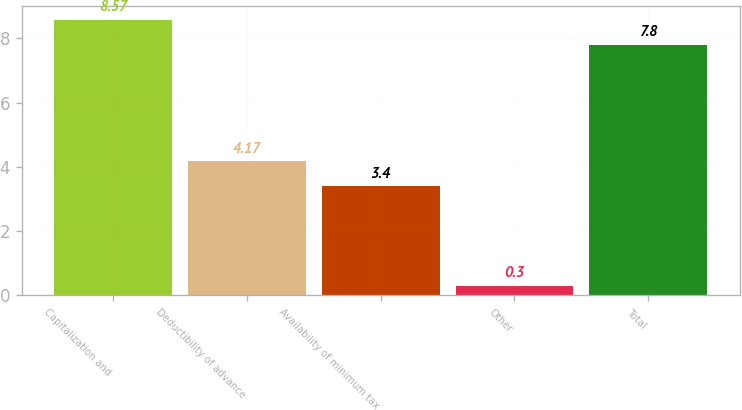<chart> <loc_0><loc_0><loc_500><loc_500><bar_chart><fcel>Capitalization and<fcel>Deductibility of advance<fcel>Availability of minimum tax<fcel>Other<fcel>Total<nl><fcel>8.57<fcel>4.17<fcel>3.4<fcel>0.3<fcel>7.8<nl></chart> 